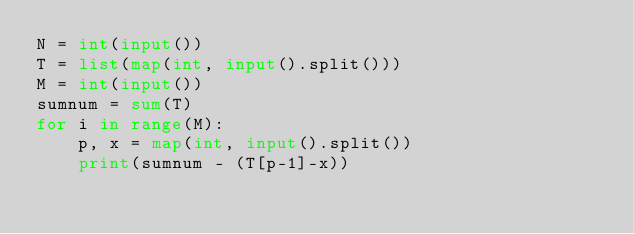Convert code to text. <code><loc_0><loc_0><loc_500><loc_500><_Python_>N = int(input())
T = list(map(int, input().split()))
M = int(input())
sumnum = sum(T)
for i in range(M):
    p, x = map(int, input().split())
    print(sumnum - (T[p-1]-x))</code> 